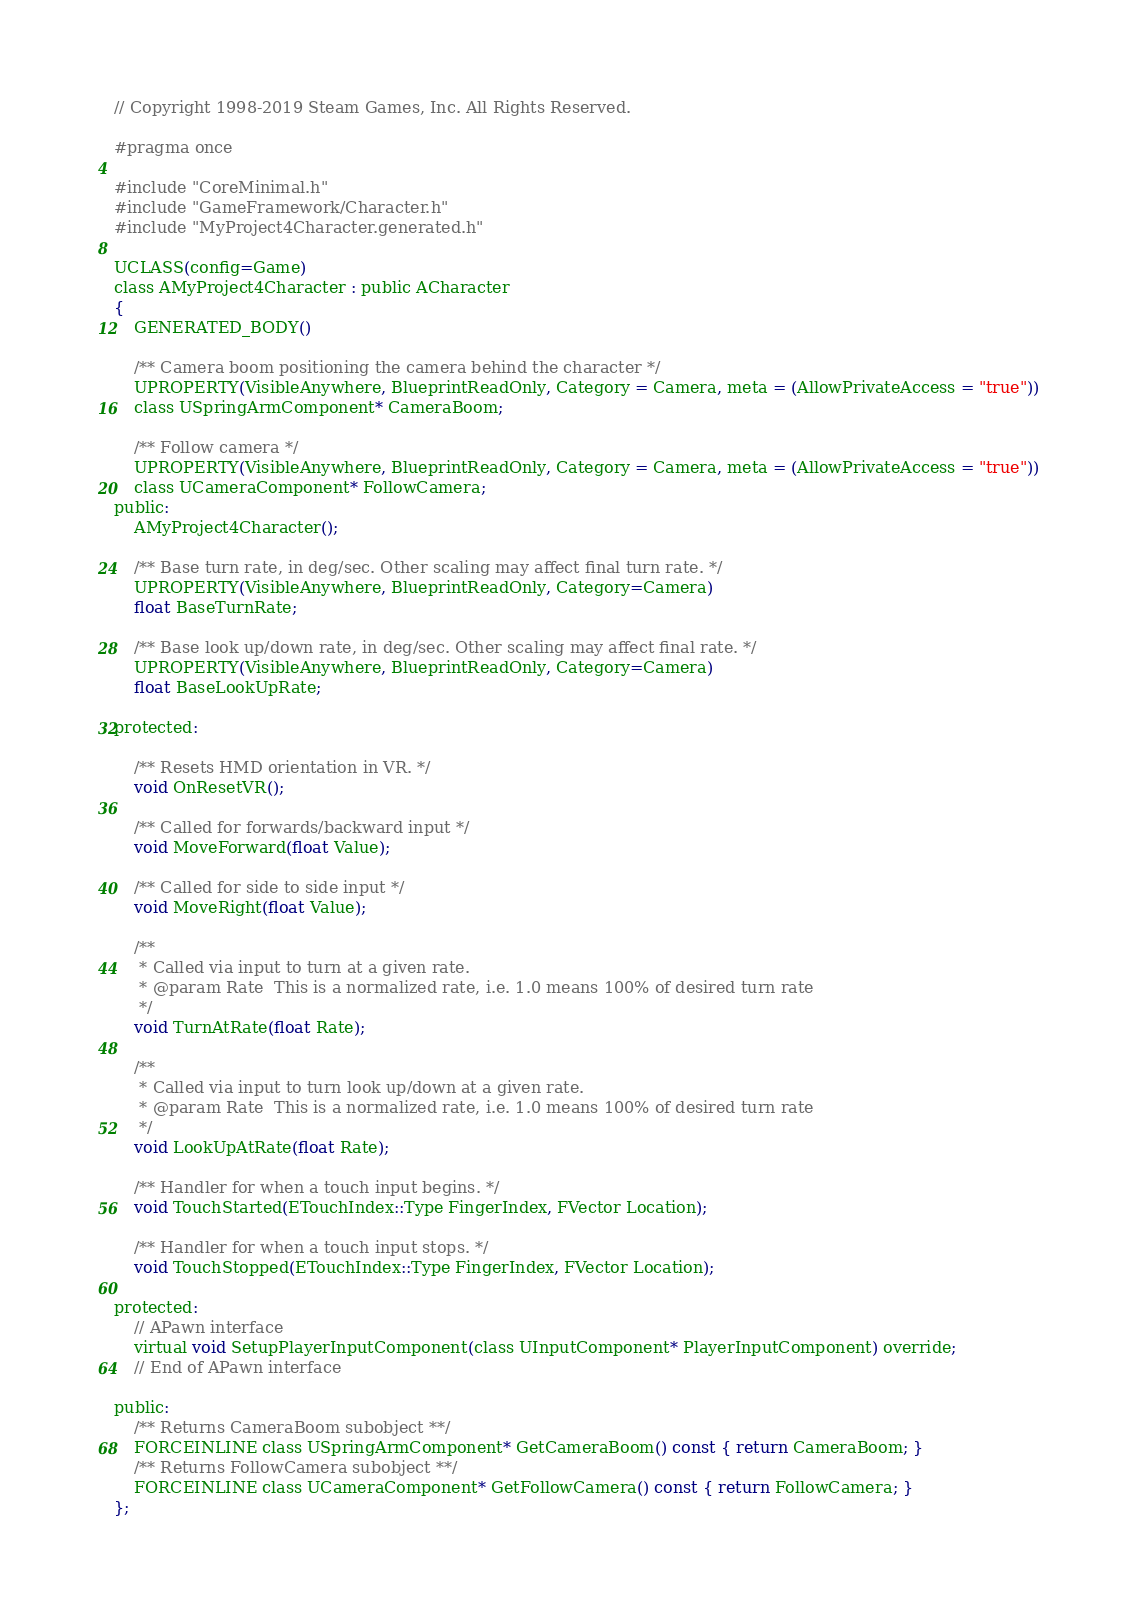<code> <loc_0><loc_0><loc_500><loc_500><_C_>// Copyright 1998-2019 Steam Games, Inc. All Rights Reserved.

#pragma once

#include "CoreMinimal.h"
#include "GameFramework/Character.h"
#include "MyProject4Character.generated.h"

UCLASS(config=Game)
class AMyProject4Character : public ACharacter
{
	GENERATED_BODY()

	/** Camera boom positioning the camera behind the character */
	UPROPERTY(VisibleAnywhere, BlueprintReadOnly, Category = Camera, meta = (AllowPrivateAccess = "true"))
	class USpringArmComponent* CameraBoom;

	/** Follow camera */
	UPROPERTY(VisibleAnywhere, BlueprintReadOnly, Category = Camera, meta = (AllowPrivateAccess = "true"))
	class UCameraComponent* FollowCamera;
public:
	AMyProject4Character();

	/** Base turn rate, in deg/sec. Other scaling may affect final turn rate. */
	UPROPERTY(VisibleAnywhere, BlueprintReadOnly, Category=Camera)
	float BaseTurnRate;

	/** Base look up/down rate, in deg/sec. Other scaling may affect final rate. */
	UPROPERTY(VisibleAnywhere, BlueprintReadOnly, Category=Camera)
	float BaseLookUpRate;

protected:

	/** Resets HMD orientation in VR. */
	void OnResetVR();

	/** Called for forwards/backward input */
	void MoveForward(float Value);

	/** Called for side to side input */
	void MoveRight(float Value);

	/** 
	 * Called via input to turn at a given rate. 
	 * @param Rate	This is a normalized rate, i.e. 1.0 means 100% of desired turn rate
	 */
	void TurnAtRate(float Rate);

	/**
	 * Called via input to turn look up/down at a given rate. 
	 * @param Rate	This is a normalized rate, i.e. 1.0 means 100% of desired turn rate
	 */
	void LookUpAtRate(float Rate);

	/** Handler for when a touch input begins. */
	void TouchStarted(ETouchIndex::Type FingerIndex, FVector Location);

	/** Handler for when a touch input stops. */
	void TouchStopped(ETouchIndex::Type FingerIndex, FVector Location);

protected:
	// APawn interface
	virtual void SetupPlayerInputComponent(class UInputComponent* PlayerInputComponent) override;
	// End of APawn interface

public:
	/** Returns CameraBoom subobject **/
	FORCEINLINE class USpringArmComponent* GetCameraBoom() const { return CameraBoom; }
	/** Returns FollowCamera subobject **/
	FORCEINLINE class UCameraComponent* GetFollowCamera() const { return FollowCamera; }
};

</code> 